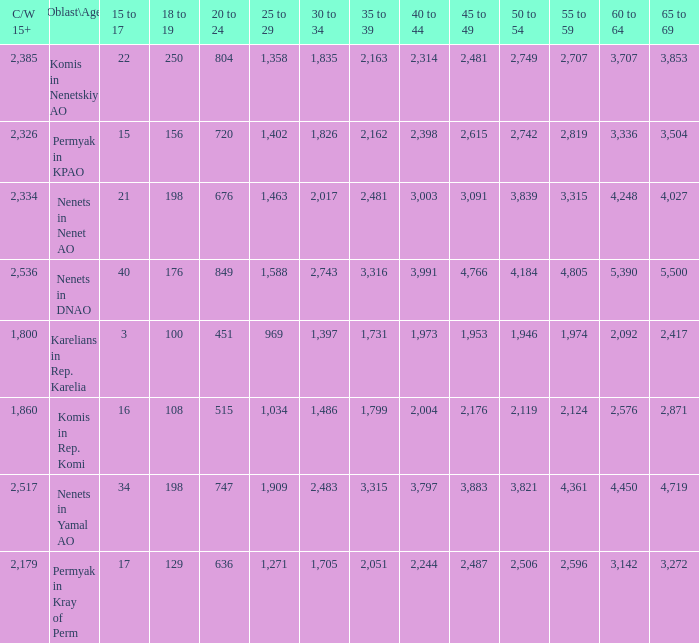What is the total 60 to 64 when the Oblast\Age is Nenets in Yamal AO, and the 45 to 49 is bigger than 3,883? None. 